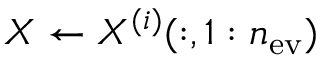Convert formula to latex. <formula><loc_0><loc_0><loc_500><loc_500>X \leftarrow X ^ { ( i ) } ( \colon , 1 \colon n _ { e v } )</formula> 